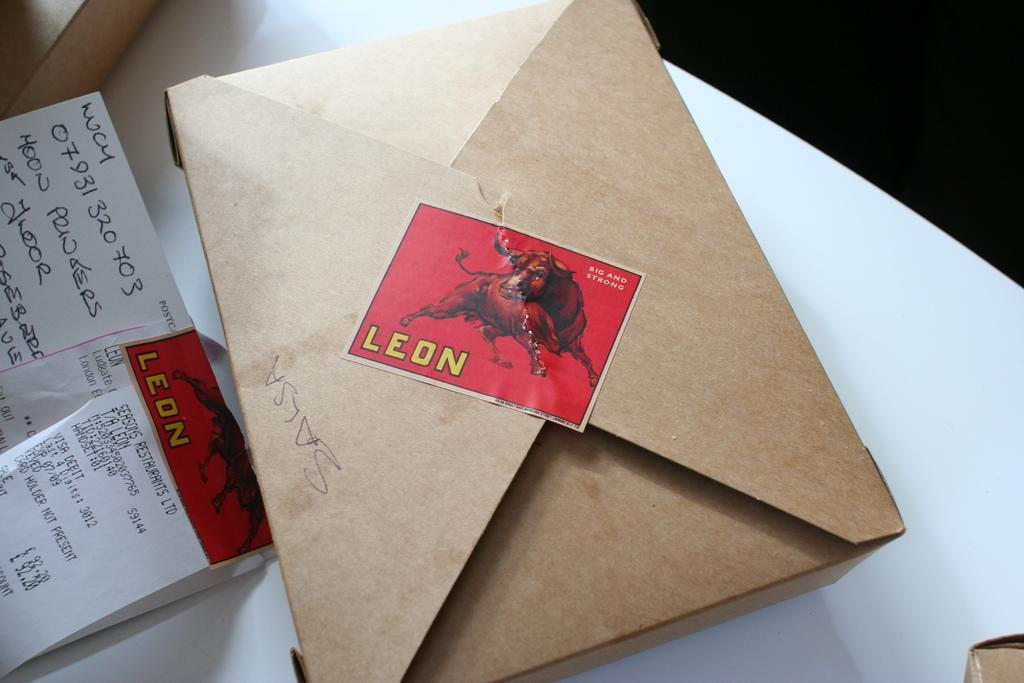<image>
Present a compact description of the photo's key features. a brown box is closed with a stamp that says leon 